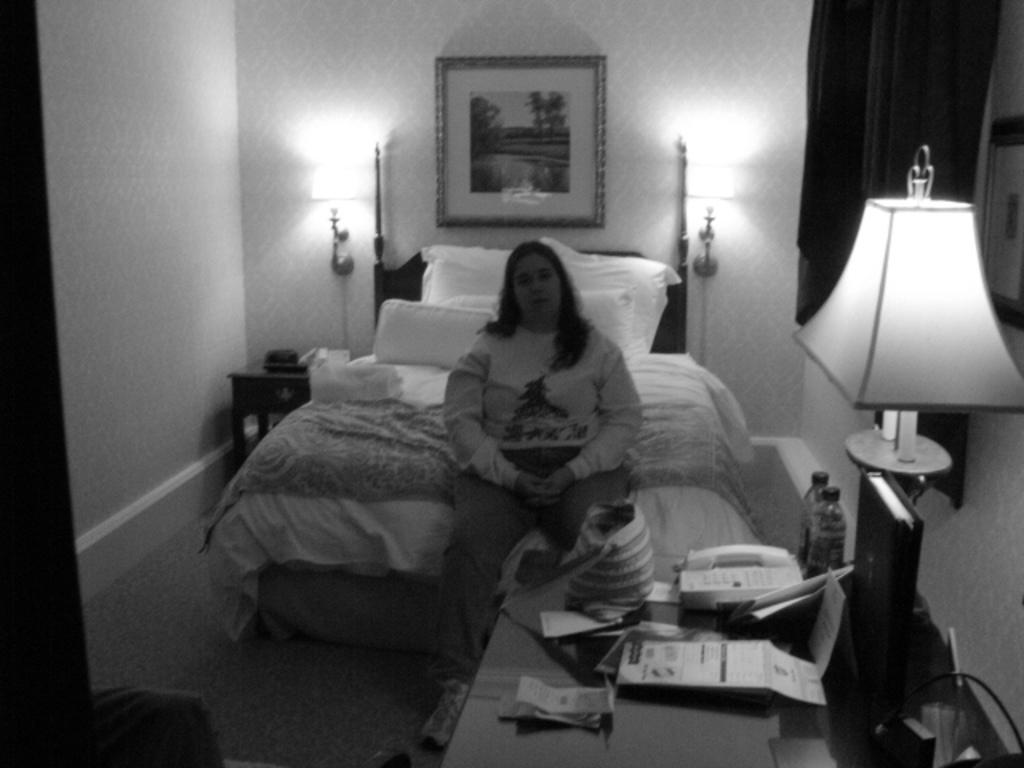Could you give a brief overview of what you see in this image? This is a black and white image. I can see a woman sitting on the bed. This bed is covered with blanket. These are the pillows placed on the bed. This is a table with telephone,papers,bottle,lamp,bag and few other things on it. These are the lamps attached to the wall. I can see a photo frame attached to the wall. 